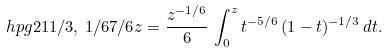Convert formula to latex. <formula><loc_0><loc_0><loc_500><loc_500>\ h p g { 2 } { 1 } { 1 / 3 , \, 1 / 6 } { 7 / 6 } { z } = \frac { z ^ { - 1 / 6 } } { 6 } \, \int _ { 0 } ^ { z } t ^ { - 5 / 6 } \, ( 1 - t ) ^ { - 1 / 3 } \, d t .</formula> 